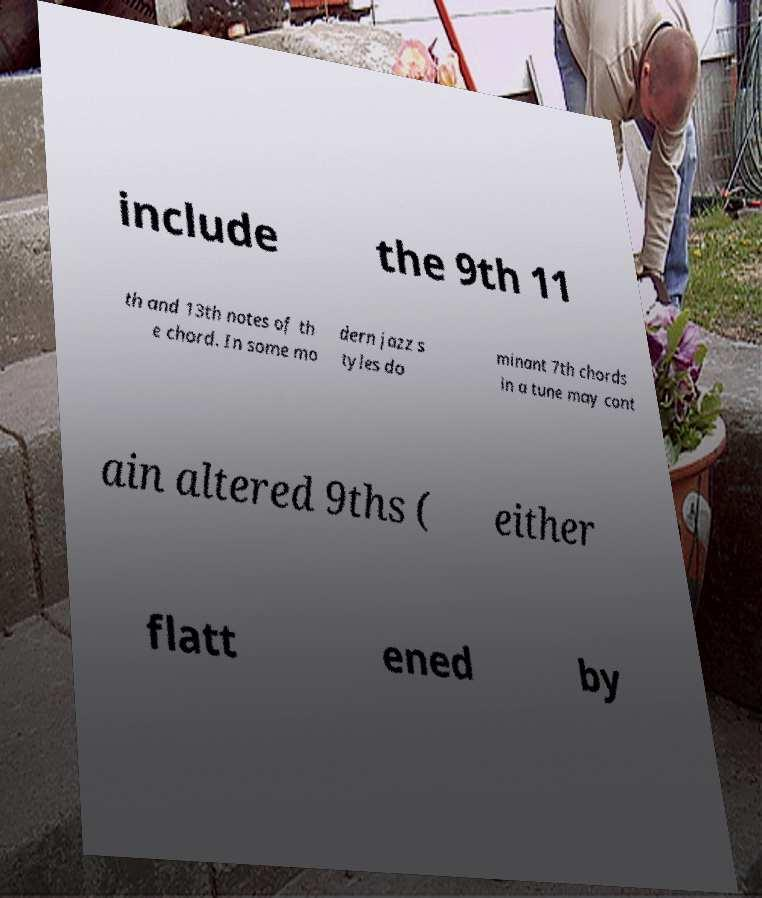Can you accurately transcribe the text from the provided image for me? include the 9th 11 th and 13th notes of th e chord. In some mo dern jazz s tyles do minant 7th chords in a tune may cont ain altered 9ths ( either flatt ened by 